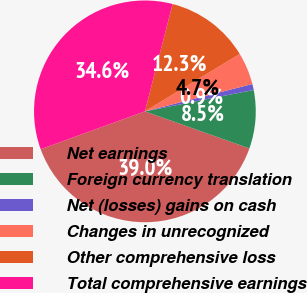Convert chart to OTSL. <chart><loc_0><loc_0><loc_500><loc_500><pie_chart><fcel>Net earnings<fcel>Foreign currency translation<fcel>Net (losses) gains on cash<fcel>Changes in unrecognized<fcel>Other comprehensive loss<fcel>Total comprehensive earnings<nl><fcel>39.03%<fcel>8.51%<fcel>0.88%<fcel>4.69%<fcel>12.32%<fcel>34.56%<nl></chart> 